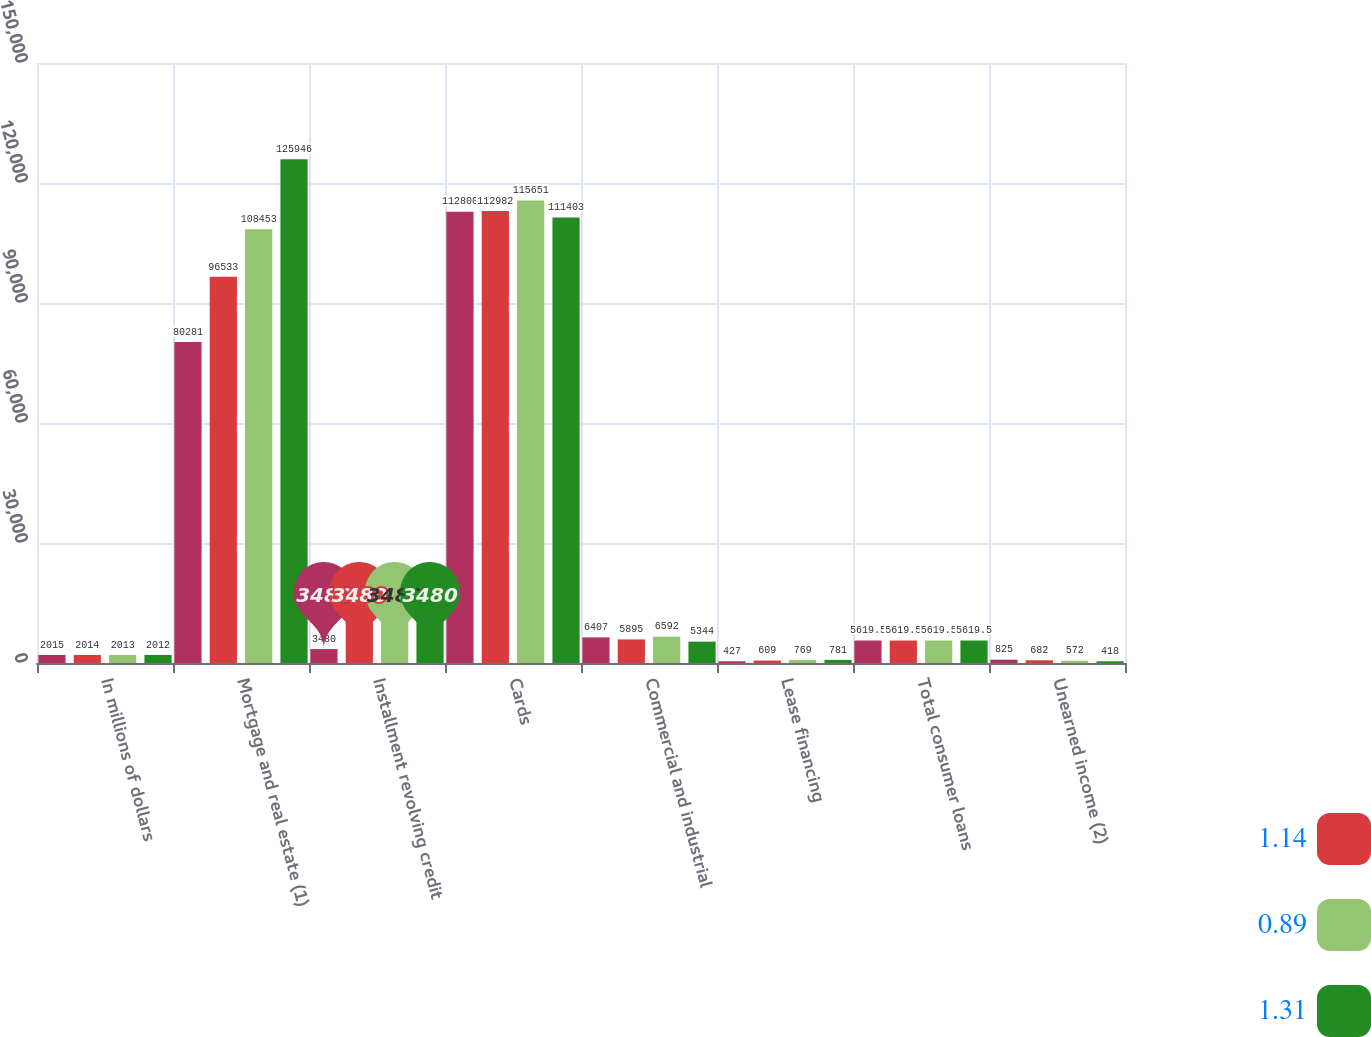Convert chart to OTSL. <chart><loc_0><loc_0><loc_500><loc_500><stacked_bar_chart><ecel><fcel>In millions of dollars<fcel>Mortgage and real estate (1)<fcel>Installment revolving credit<fcel>Cards<fcel>Commercial and industrial<fcel>Lease financing<fcel>Total consumer loans<fcel>Unearned income (2)<nl><fcel>nan<fcel>2015<fcel>80281<fcel>3480<fcel>112800<fcel>6407<fcel>427<fcel>5619.5<fcel>825<nl><fcel>1.14<fcel>2014<fcel>96533<fcel>14450<fcel>112982<fcel>5895<fcel>609<fcel>5619.5<fcel>682<nl><fcel>0.89<fcel>2013<fcel>108453<fcel>13398<fcel>115651<fcel>6592<fcel>769<fcel>5619.5<fcel>572<nl><fcel>1.31<fcel>2012<fcel>125946<fcel>14070<fcel>111403<fcel>5344<fcel>781<fcel>5619.5<fcel>418<nl></chart> 